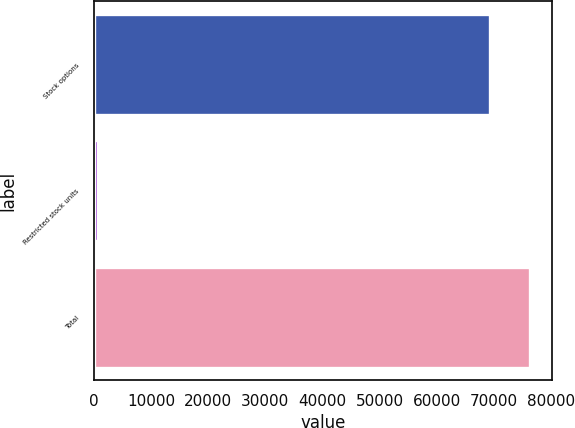Convert chart. <chart><loc_0><loc_0><loc_500><loc_500><bar_chart><fcel>Stock options<fcel>Restricted stock units<fcel>Total<nl><fcel>69395<fcel>735<fcel>76334.5<nl></chart> 